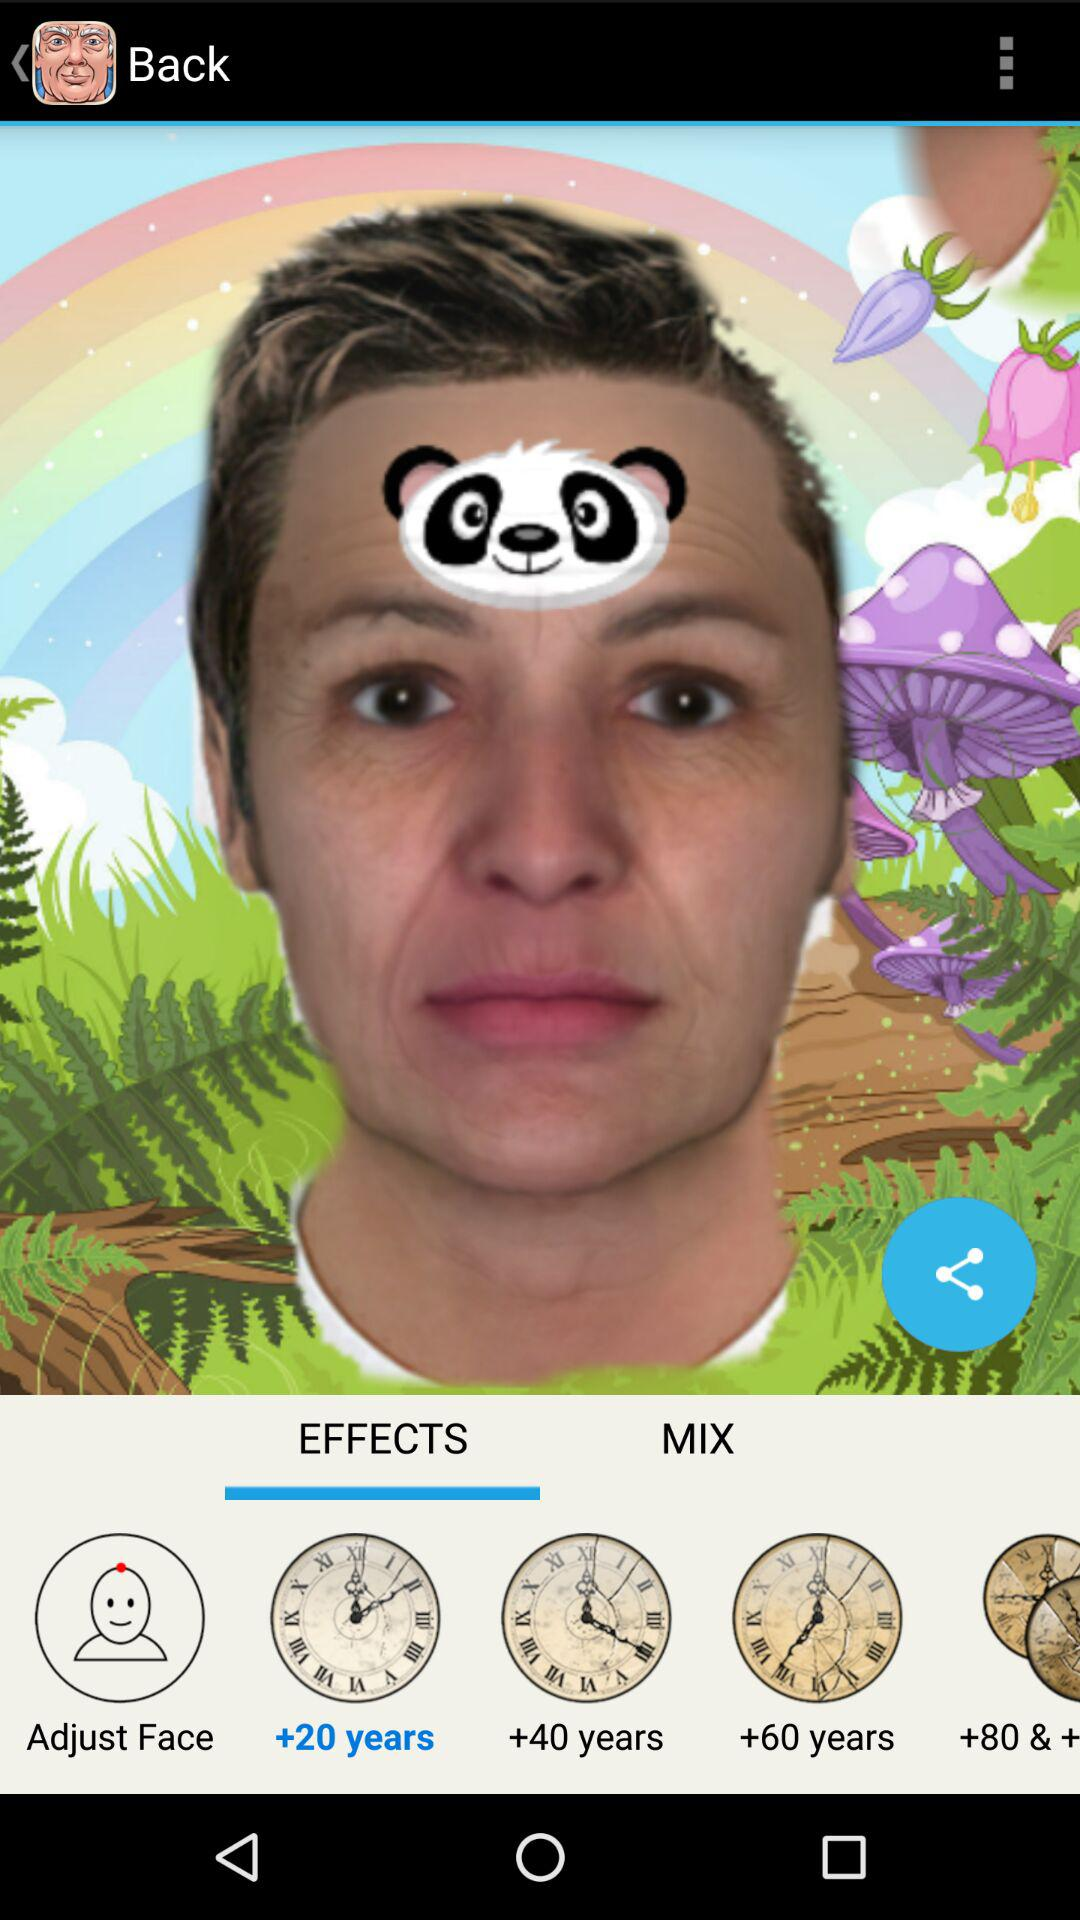Which effects is selected? The selected effects is +20 years. 